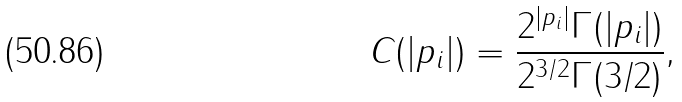Convert formula to latex. <formula><loc_0><loc_0><loc_500><loc_500>C ( | p _ { i } | ) = \frac { 2 ^ { | p _ { i } | } \Gamma ( | p _ { i } | ) } { 2 ^ { 3 / 2 } \Gamma ( 3 / 2 ) } ,</formula> 